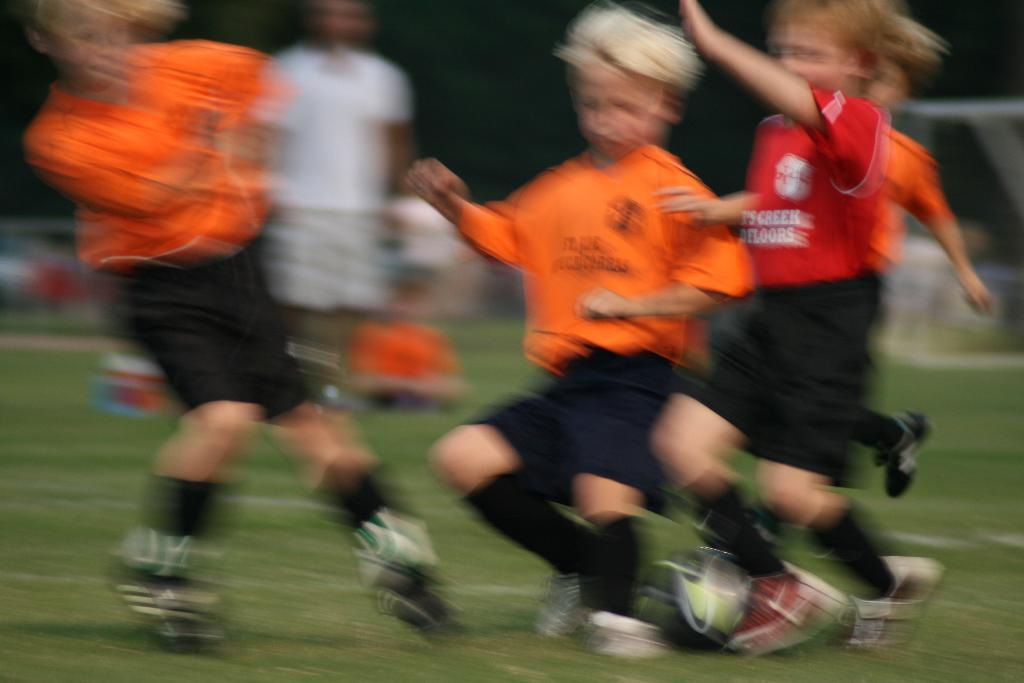Where was the image taken? The image was clicked in a ground. How would you describe the quality of the image? The image is blurred. How many children are present in the image? There are four children in the image. What activity are the children engaged in? The children are playing football. What type of surface is visible at the bottom of the image? There is green grass at the bottom of the image. What type of throat lozenges can be seen in the image? There are no throat lozenges present in the image. Can you provide a list of fruits that are visible in the image? There are no fruits visible in the image; it features four children playing football on a grassy surface. 